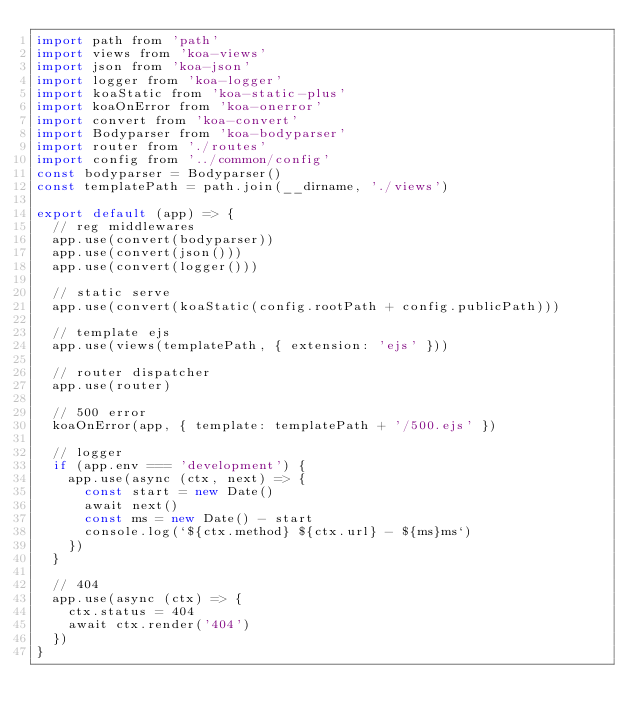<code> <loc_0><loc_0><loc_500><loc_500><_JavaScript_>import path from 'path'
import views from 'koa-views'
import json from 'koa-json'
import logger from 'koa-logger'
import koaStatic from 'koa-static-plus'
import koaOnError from 'koa-onerror'
import convert from 'koa-convert'
import Bodyparser from 'koa-bodyparser'
import router from './routes'
import config from '../common/config'
const bodyparser = Bodyparser()
const templatePath = path.join(__dirname, './views')

export default (app) => {
  // reg middlewares
  app.use(convert(bodyparser))
  app.use(convert(json()))
  app.use(convert(logger()))

  // static serve
  app.use(convert(koaStatic(config.rootPath + config.publicPath)))

  // template ejs
  app.use(views(templatePath, { extension: 'ejs' }))

  // router dispatcher
  app.use(router)

  // 500 error
  koaOnError(app, { template: templatePath + '/500.ejs' })

  // logger
  if (app.env === 'development') {
    app.use(async (ctx, next) => {
      const start = new Date()
      await next()
      const ms = new Date() - start
      console.log(`${ctx.method} ${ctx.url} - ${ms}ms`)
    })
  }

  // 404
  app.use(async (ctx) => {
    ctx.status = 404
    await ctx.render('404')
  })
}
</code> 